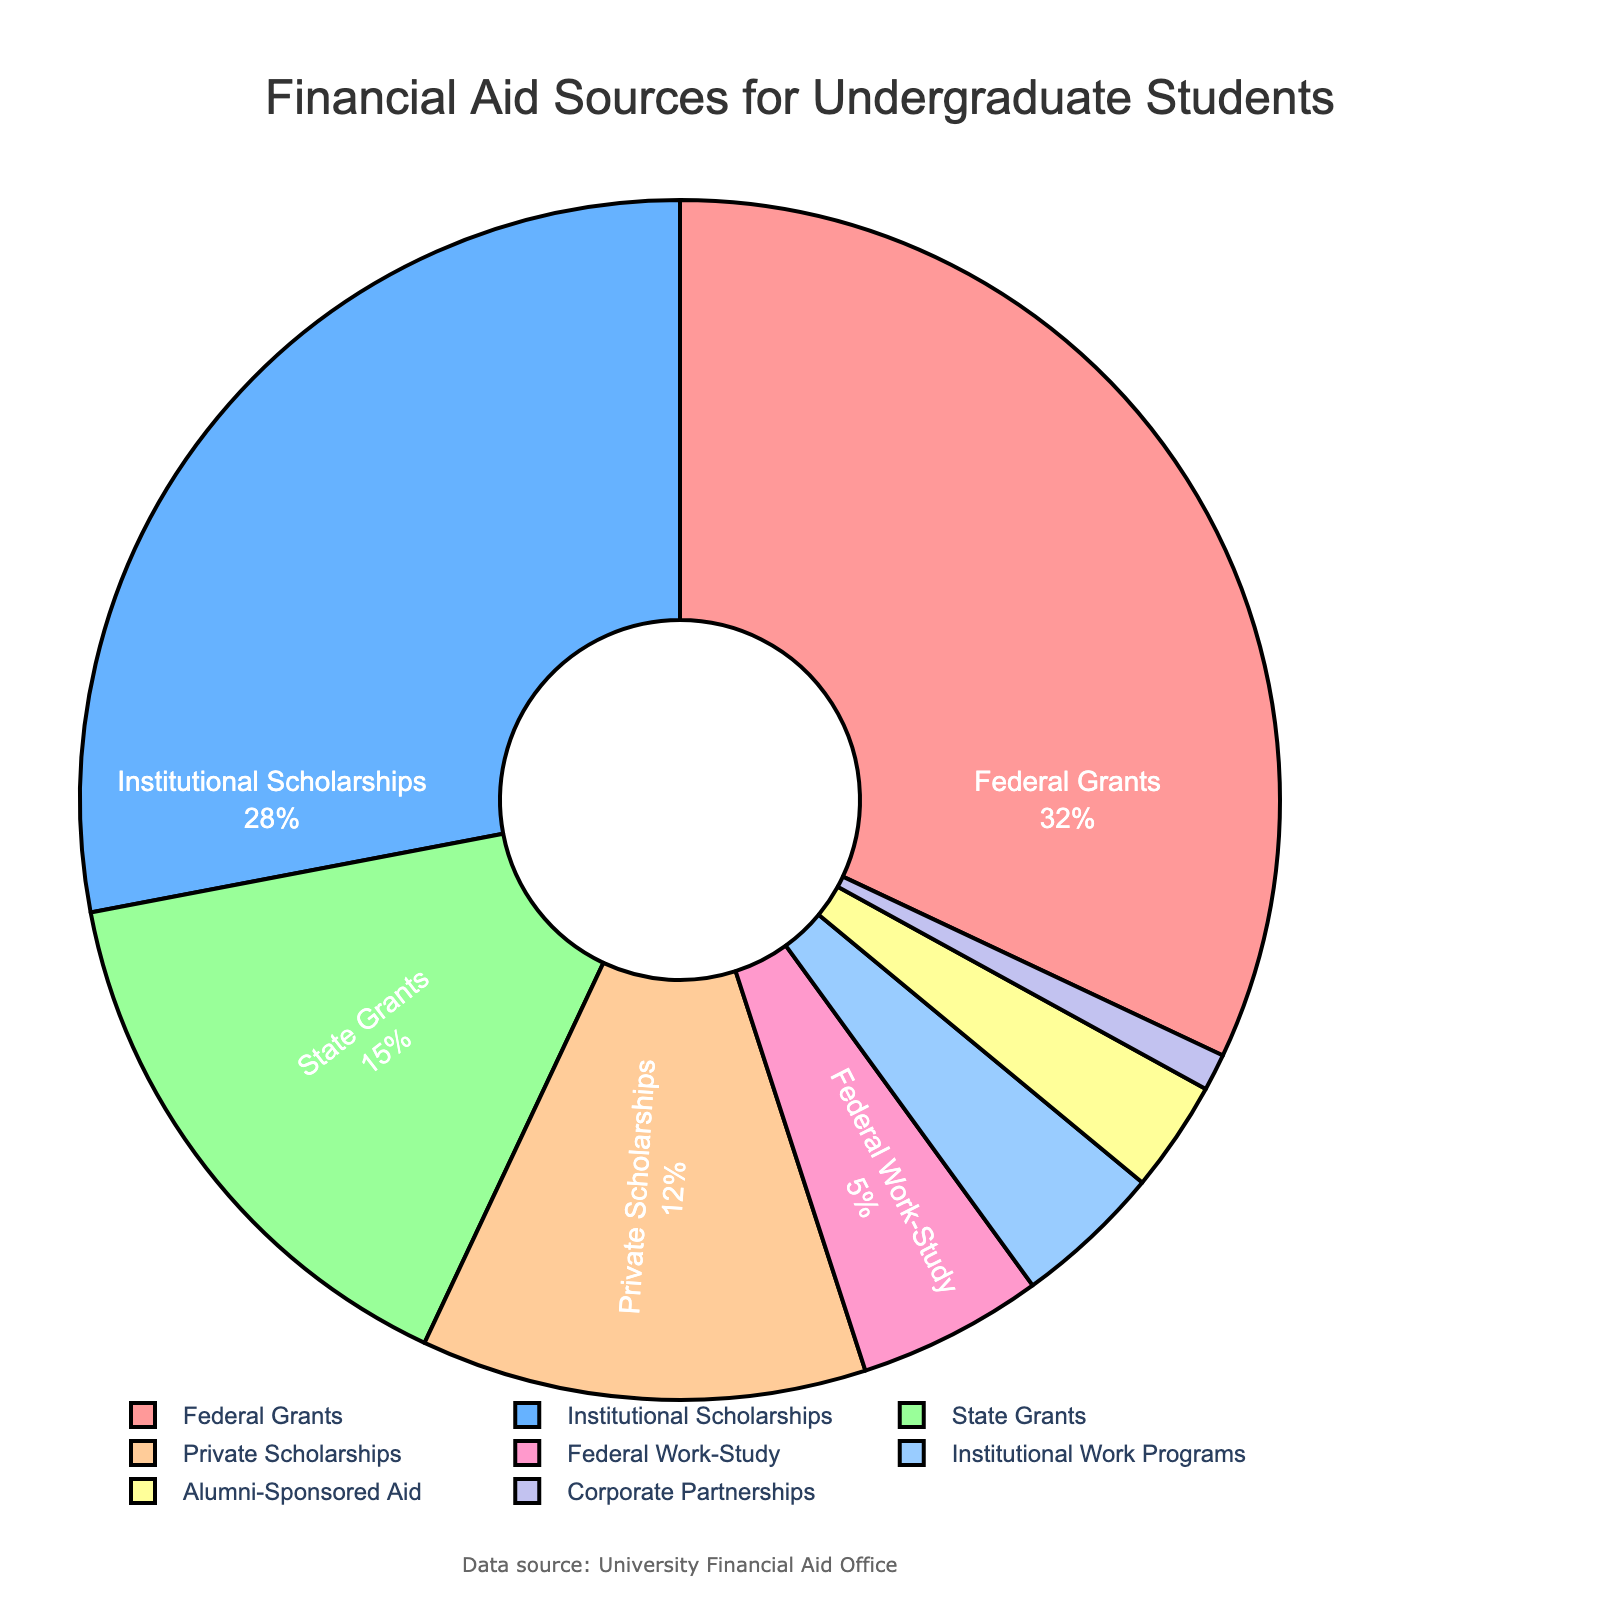What percentage of financial aid comes from federal sources? To find the percentage of financial aid from federal sources, sum the percentages of Federal Grants and Federal Work-Study. Federal Grants account for 32%, and Federal Work-Study accounts for 5%. So, 32% + 5% = 37%.
Answer: 37% Which financial aid source provides the most aid? To determine the source that provides the most aid, look at the source with the largest percentage. Federal Grants account for 32%, which is the largest percentage among all sources.
Answer: Federal Grants How much more aid do Institutional Scholarships provide compared to Private Scholarships? Institutional Scholarships provide 28% while Private Scholarships provide 12%. The difference is 28% - 12% = 16%.
Answer: 16% What is the combined percentage of aid provided by State Grants and Private Scholarships? To find the combined percentage, sum the percentages of State Grants and Private Scholarships. State Grants are 15% and Private Scholarships are 12%. So, 15% + 12% = 27%.
Answer: 27% Which aid source has a lower percentage: Alumni-Sponsored Aid or Institutional Work Programs? Compare the percentages of Alumni-Sponsored Aid and Institutional Work Programs. Alumni-Sponsored Aid is 3% and Institutional Work Programs are 4%. Therefore, Alumni-Sponsored Aid has a lower percentage.
Answer: Alumni-Sponsored Aid How many financial aid sources provide less than 10% of the total aid each? To answer, identify the sources with percentages less than 10%: Private Scholarships (12% is not less than 10%), Federal Work-Study (5%), Institutional Work Programs (4%), Alumni-Sponsored Aid (3%), and Corporate Partnerships (1%). There are 4 sources that provide less than 10%.
Answer: 4 Which financial aid sources combined form more than 50% of the total aid? Sum the percentages starting from the largest until the total exceeds 50%. Federal Grants (32%) + Institutional Scholarships (28%) = 60%. These two sources combined form more than 50% of the total aid.
Answer: Federal Grants and Institutional Scholarships What is the average percentage of aid provided by State Grants, Private Scholarships, and Alumni-Sponsored Aid? To find the average percentage, sum the percentages of State Grants, Private Scholarships, and Alumni-Sponsored Aid, and then divide by 3. The percentages are 15%, 12%, and 3% respectively. So, (15% + 12% + 3%) / 3 = 10%.
Answer: 10% Is Federal Work-Study percentage greater than Institutional Work Programs percentage? To determine this, compare both percentages. Federal Work-Study is 5% and Institutional Work Programs are 4%. Federal Work-Study has a higher percentage than Institutional Work Programs.
Answer: Yes 